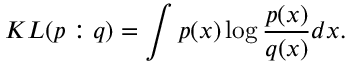Convert formula to latex. <formula><loc_0><loc_0><loc_500><loc_500>K L ( p \colon q ) = \int p ( x ) \log { \frac { p ( x ) } { q ( x ) } } d x .</formula> 